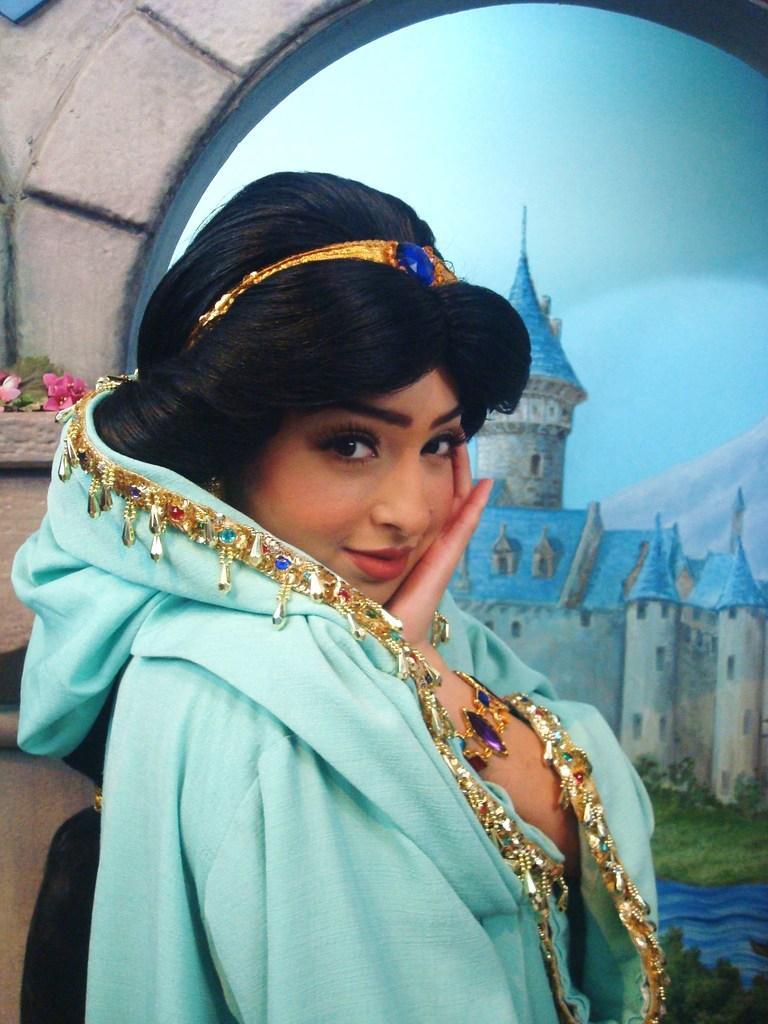Can you describe this image briefly? In the image we can see a woman wearing clothes and she is smiling. Here we can see the painting, in the painting we can see the building, grass, water and the sky. 